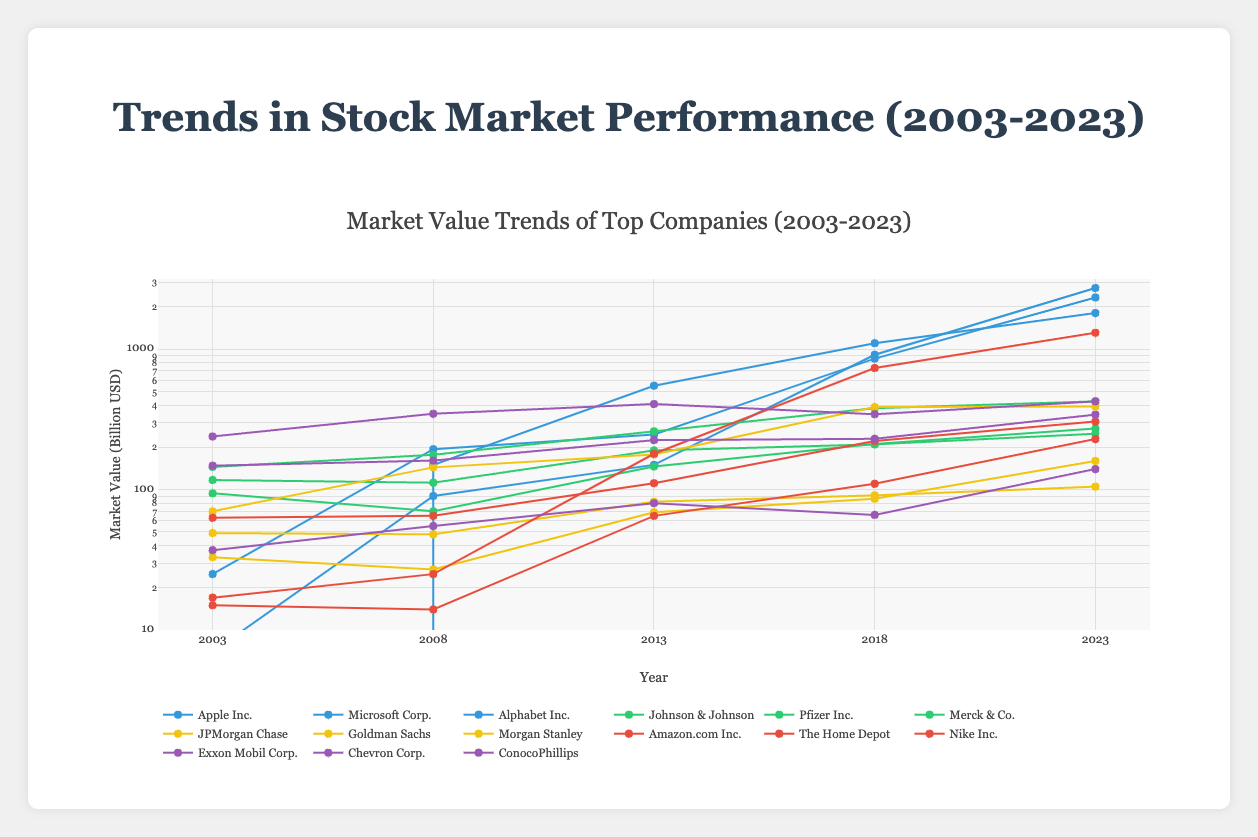Which sector does Apple Inc. belong to? Apple Inc. belongs to the Technology sector, as indicated in the legend where the company's line color matches the color code for Technology.
Answer: Technology What is the market value trend for Microsoft Corp. between 2003 and 2023? To find the trend, observe Microsoft Corp.'s values in 2003 ($25 billion), 2008 ($194 billion), 2013 ($247 billion), 2018 ($857 billion), and 2023 ($2334 billion). The trend shows a substantial increase in market value over these years.
Answer: Increasing What was Pfizer Inc.'s market value in 2023? Look at the plotted data for Pfizer Inc. in 2023, which is labeled along the x-axis. The corresponding y-value is $250 billion.
Answer: $250 billion Which company in the Energy sector has the highest market value in 2023? Compare the 2023 market values of companies in the Energy sector: Exxon Mobil ($425 billion), Chevron ($342 billion), ConocoPhillips ($140 billion). Exxon Mobil has the highest value.
Answer: Exxon Mobil How much did Amazon.com Inc.'s market value increase from 2013 to 2023? Check Amazon.com Inc.'s market values for 2013 ($180 billion) and 2023 ($1310 billion). Calculate the difference: $1310 billion - $180 billion = $1130 billion.
Answer: $1130 billion Which sector shows the most significant growth from 2003 to 2023? Compare the trends in market values for different sectors by checking the starting (2003) and ending (2023) values for representative companies. The Technology sector, especially with Apple Inc. and Microsoft Corp., shows the most significant growth.
Answer: Technology Between 2018 and 2023, which company in the Healthcare sector showed the greatest increase in market value? Compare the market values of companies in the Healthcare sector (Johnson & Johnson, Pfizer Inc., Merck & Co.) between 2018 and 2023: Johnson & Johnson ($45 billion), Pfizer Inc. ($40 billion), Merck & Co. ($61 billion). Merck & Co. shows the greatest increase of 61 billion.
Answer: Merck & Co What is the average market value of JPMorgan Chase over the 5 recorded years? Calculate the mean of JPMorgan Chase's values over the years: (70 + 144 + 178 + 387 + 390) / 5 = 1169 / 5 = 233.8 billion.
Answer: $233.8 billion Which company had the lowest market value in 2008? Compare the market values in 2008 for all companies and find the lowest: Nike Inc. ($14 billion).
Answer: Nike Inc How does the year 2008 impact the market values across different sectors? Look at the changes in market values from 2003 to 2008 for all sectors. Some sectors saw significant increases (e.g., Technology), while others remained mostly stable or had slight decreases (e.g., Healthcare, Financials).
Answer: Mixed responses: Technology increased significantly, others varied 